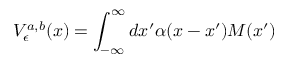<formula> <loc_0><loc_0><loc_500><loc_500>V _ { \epsilon } ^ { a , b } ( x ) = \int _ { - \infty } ^ { \infty } d x ^ { \prime } \alpha ( x - x ^ { \prime } ) M ( x ^ { \prime } )</formula> 